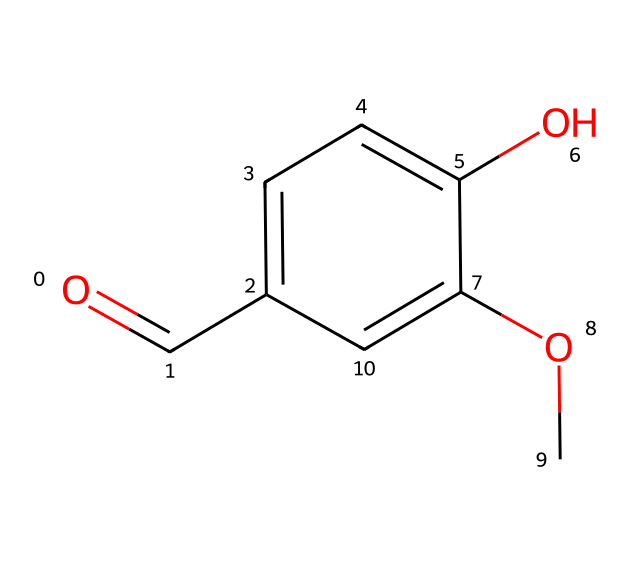What is the molecular formula of vanillin? To determine the molecular formula, we count the number of each type of atom present in the structure. The SMILES representation indicates the presence of carbon (C), hydrogen (H), and oxygen (O). Upon counting, we find 8 carbon atoms, 8 hydrogen atoms, and 3 oxygen atoms, giving us the formula C8H8O3.
Answer: C8H8O3 How many rings does the chemical structure contain? Looking at the SMILES representation, we identify that there is one aromatic ring present in the structure, which can be seen from the “c” letters indicating the carbon atoms in the ring.
Answer: 1 What functional groups are present in vanillin? Analyzing the SMILES representation, we can identify three functional groups: a carbonyl group (C=O), a hydroxyl group (-OH, indicated by "O"), and a methoxy group (-OCH3).
Answer: carbonyl, hydroxyl, methoxy What type of reaction can vanillin undergo involving its hydroxyl group? The presence of the hydroxyl group makes vanillin capable of undergoing oxidation reactions, which often involve losing hydrogen to form a carbonyl or participating in esterification.
Answer: oxidation What is the significance of the methoxy group in vanillin? The methoxy group increases the solubility of vanillin in organic solvents and contributes to the compound's aromatic properties, enhancing its flavor profile.
Answer: increases solubility How does the structure of vanillin affect its aroma? The overall combination of the aromatic ring, hydroxyl group, and methoxy group interacts with olfactory receptors, which is key to vanillin's characteristic sweet, vanilla scent.
Answer: contributes to aroma 